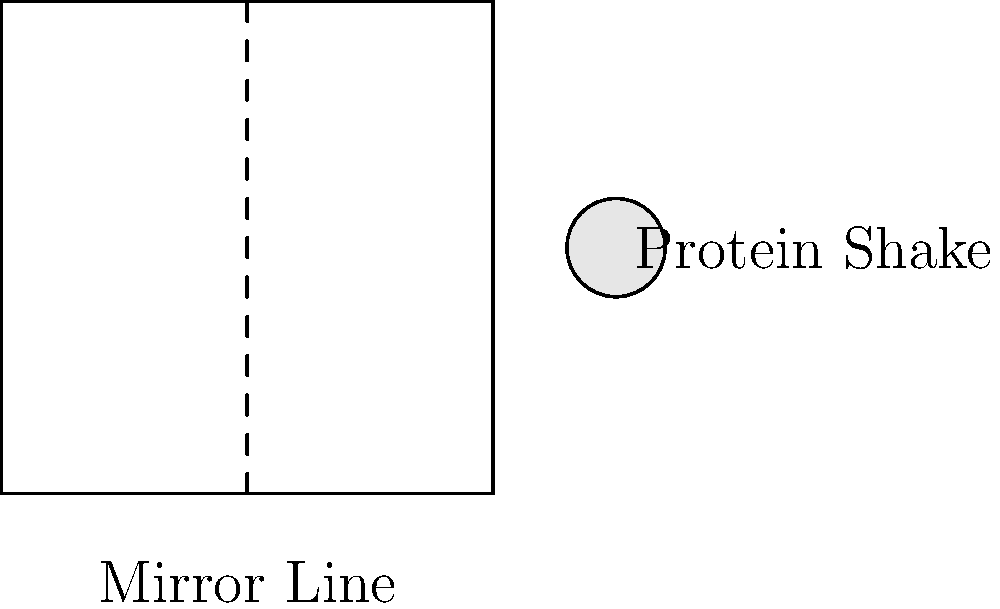A protein shake bottle is placed at point (2.5,1) on a coordinate plane. If it's reflected across the line x=1, what will be the coordinates of the reflected bottle? To solve this problem, we'll follow these steps:

1. Identify the original position: The protein shake bottle is at (2.5, 1).

2. Recognize the mirror line: The line of reflection is x = 1.

3. Calculate the distance from the original point to the mirror line:
   Distance = 2.5 - 1 = 1.5 units

4. Reflect the point:
   - The y-coordinate remains the same (1) because the mirror line is vertical.
   - The x-coordinate will be the same distance on the other side of the mirror line.
   - New x-coordinate = 1 - 1.5 = -0.5

5. Therefore, the reflected point will be at (-0.5, 1).

This reflection demonstrates line symmetry, where the mirror line acts as the axis of symmetry.
Answer: (-0.5, 1) 